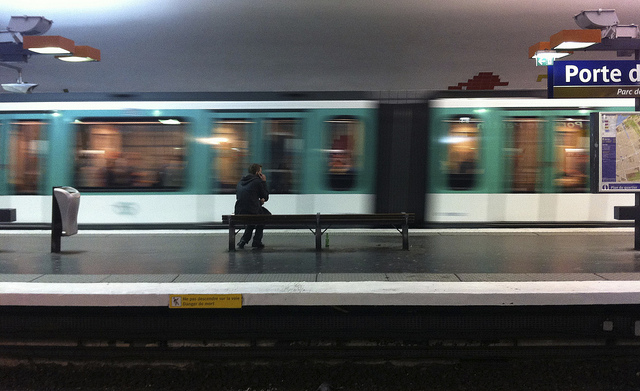Read and extract the text from this image. Porte 